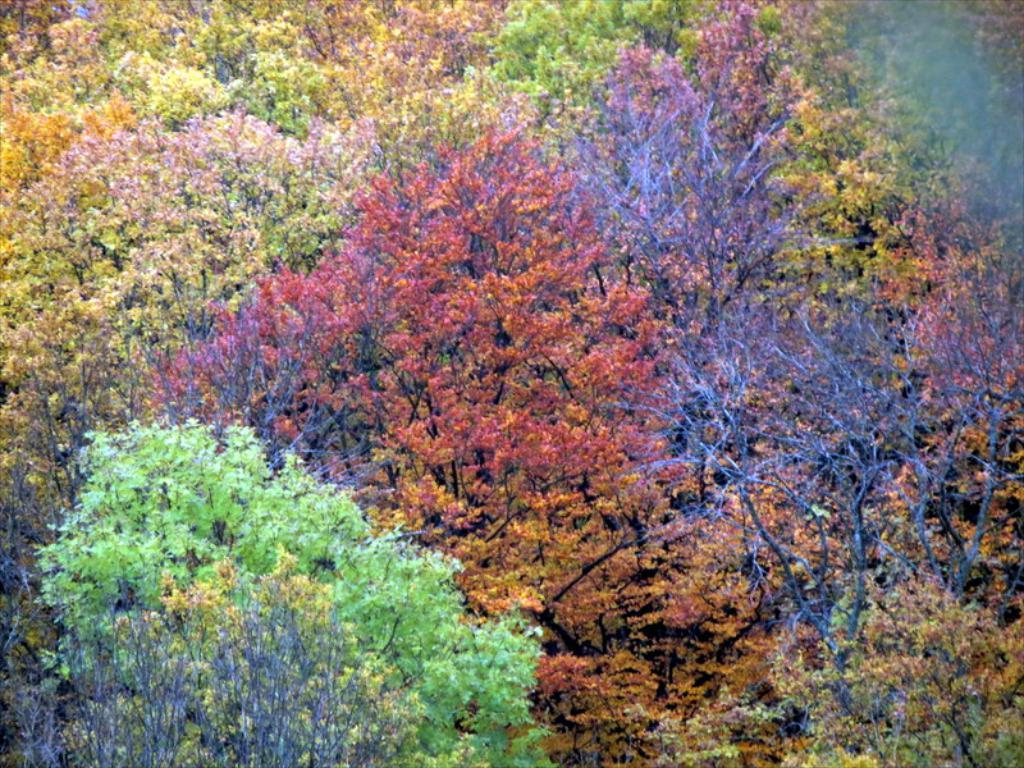What type of vegetation can be seen in the image? There are trees in the image. What is unique about the leaves on the trees? The leaves on the trees have colorful hues. What type of building can be seen in the image? There is no building present in the image; it only features trees with colorful leaves. How does the comb help in creating the jelly in the image? There is no comb or jelly present in the image; it only features trees with colorful leaves. 